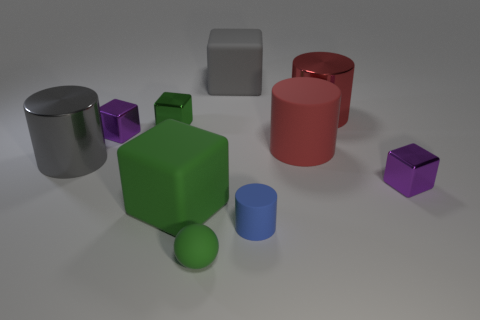There is a large red thing that is in front of the green metal object; what shape is it? The large red object situated in front of the green metal object is cylindrical in shape, featuring smooth curved surfaces and circular ends, typical of a cylinder. 